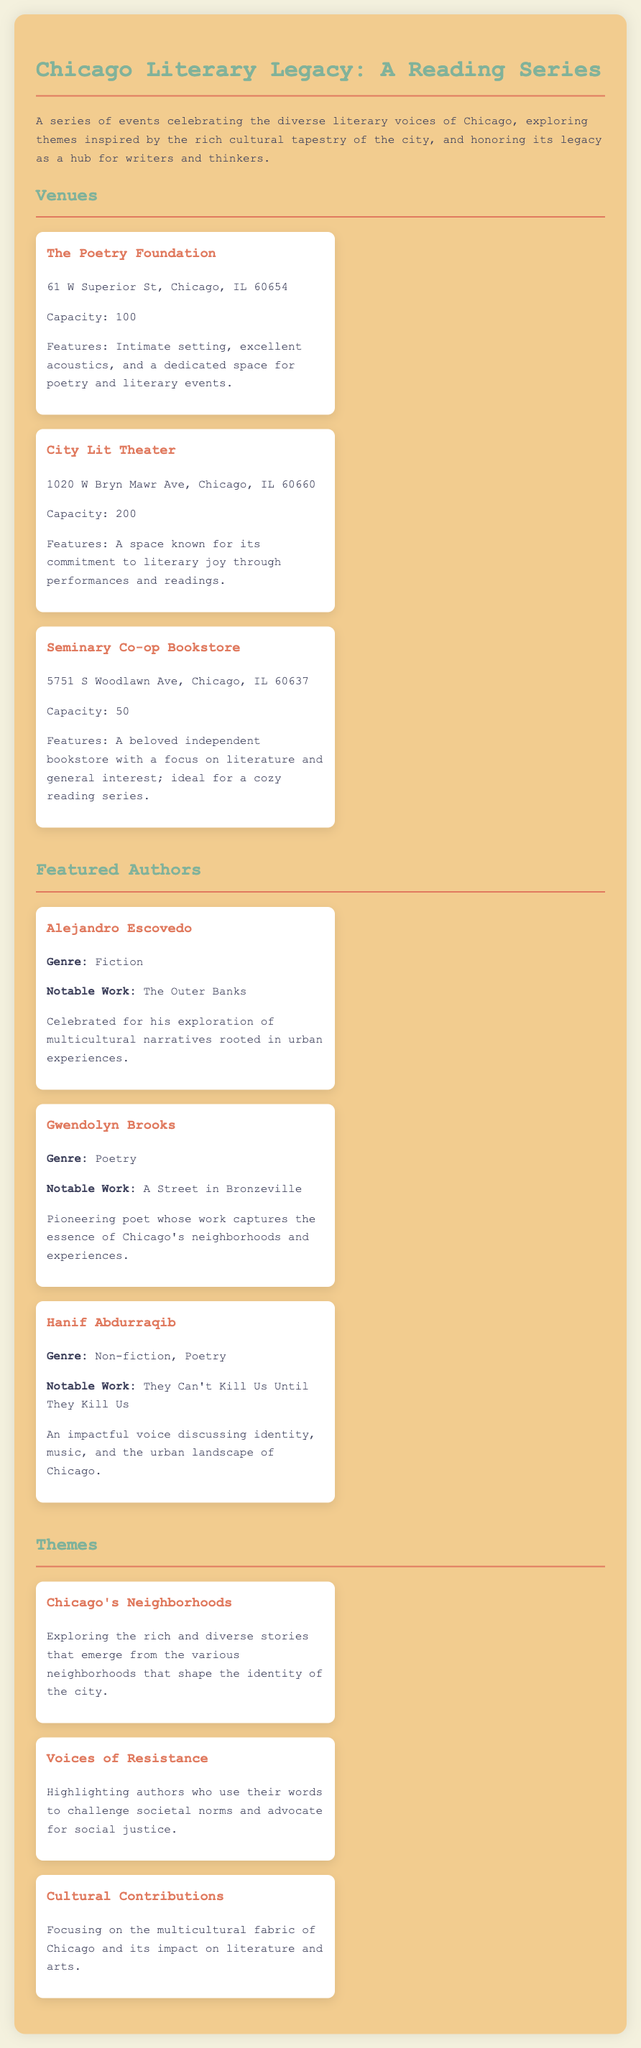What is the title of the reading series? The title of the reading series is mentioned at the beginning of the document.
Answer: Chicago Literary Legacy: A Reading Series How many venues are listed in the document? The document lists three distinct venues for the reading series.
Answer: 3 What is the capacity of The Poetry Foundation? The capacity is specified in the details of The Poetry Foundation venue.
Answer: 100 Who is the author of "A Street in Bronzeville"? The document includes this information under featured authors, allowing identification of the author.
Answer: Gwendolyn Brooks What theme focuses on multicultural contributions? The document outlines various themes; this one is specifically about cultural impact in literature.
Answer: Cultural Contributions Which venue has a capacity of 50? This question relies on the listed capacities of the venues to identify the specific one.
Answer: Seminary Co-op Bookstore What genre does Hanif Abdurraqib primarily write in? The list of authors includes their genres, providing insight into the primary genre of Hanif Abdurraqib.
Answer: Non-fiction, Poetry What is a key theme addressing societal challenges? The document discusses themes, and this one highlights authors who speak on social justice.
Answer: Voices of Resistance 